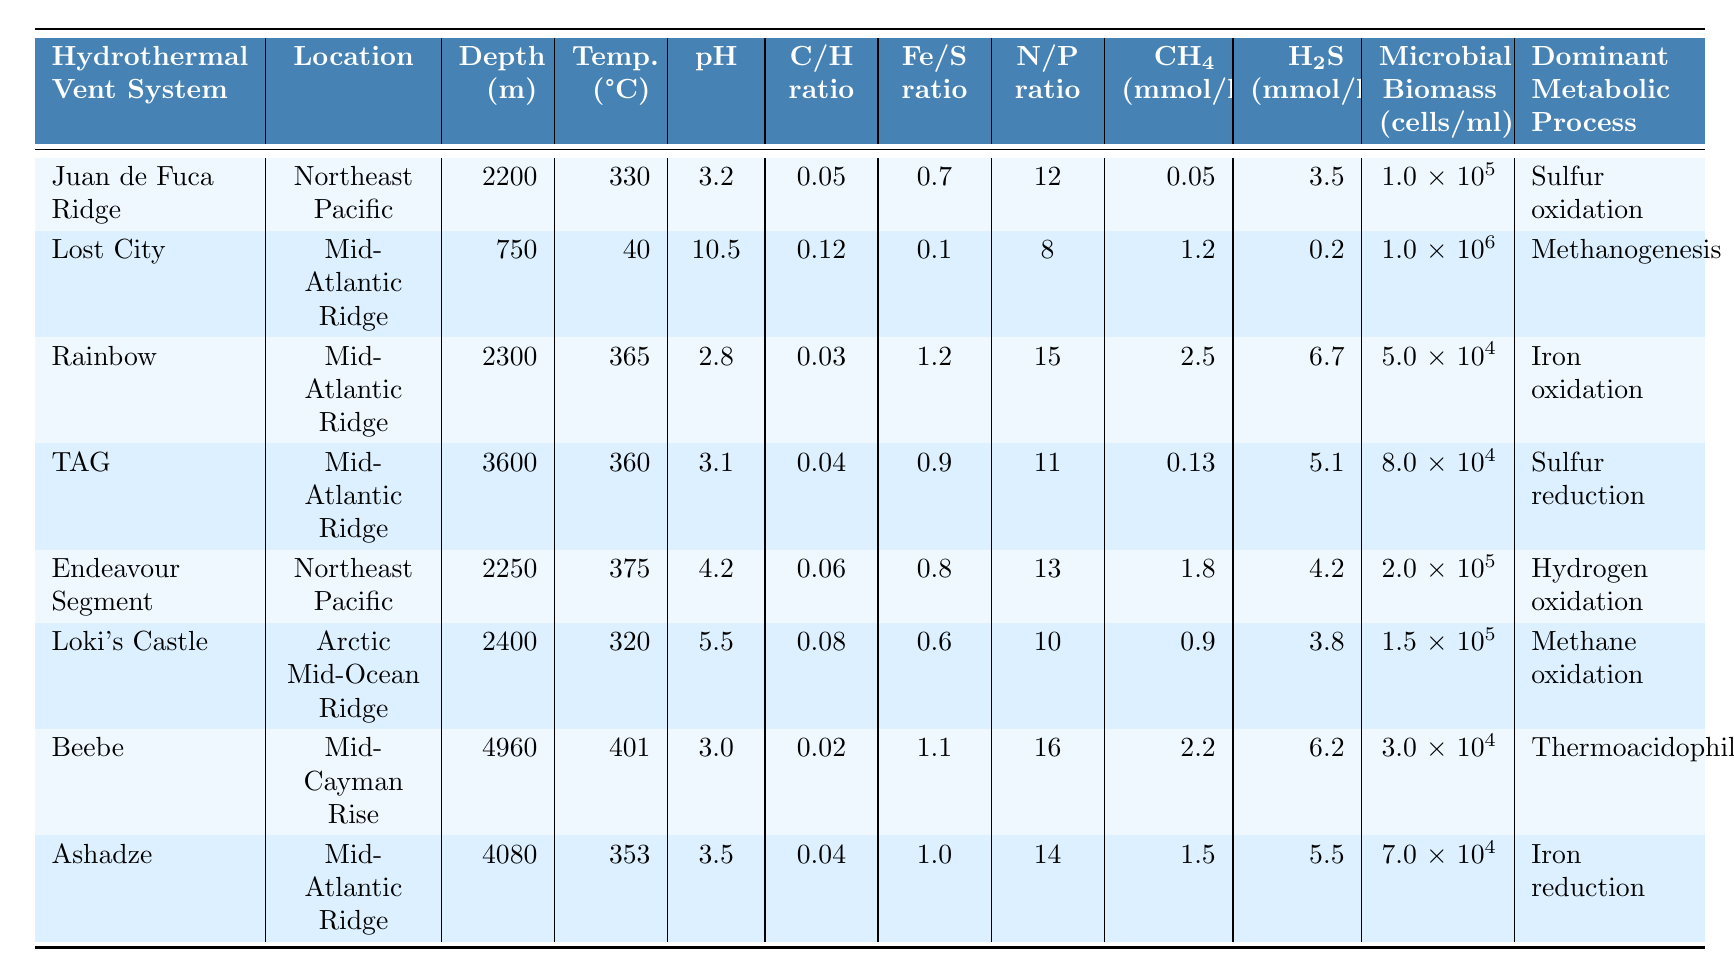What is the highest temperature recorded among the hydrothermal vent systems? Among all the entries in the table, the temperature values are listed as follows: 330, 40, 365, 360, 375, 320, 401, and 353 °C. The highest value is 375 °C from the Endeavour Segment.
Answer: 375 °C Which hydrothermal vent system has the lowest pH value? The pH values listed in the table are: 3.2, 10.5, 2.8, 3.1, 4.2, 5.5, 3.0, and 3.5. The lowest value among these is 2.8, which corresponds to the Rainbow hydrothermal vent system.
Answer: Rainbow What is the C/H ratio for the Lost City hydrothermal vent system? Looking at the table, the C/H ratio for the Lost City is specified to be 0.12.
Answer: 0.12 Calculate the average N/P ratio across all listed hydrothermal vent systems. The N/P ratios provided are 12, 8, 15, 11, 13, 10, 16, and 14. To find the average, we sum these values: 12 + 8 + 15 + 11 + 13 + 10 + 16 + 14 = 99. Then we divide by 8 (the number of systems): 99 / 8 = 12.375.
Answer: 12.375 Which hydrothermal vent system has a higher Methane concentration, Loki's Castle or TAG? From the table, the Methane concentrations are listed as follows: Loki's Castle has 0.9 mmol/kg and TAG has 0.13 mmol/kg. Since 0.9 is greater than 0.13, Loki's Castle has the higher Methane concentration.
Answer: Loki's Castle Is there a hydrothermal vent system with a microbial biomass greater than 1 million cells per milliliter? By reviewing the microbial biomass values: 1e5, 1e6, 5e4, 8e4, 2e5, 1.5e5, 3e4, and 7e4. The value 1e6 is the only one that represents 1 million cells/ml, which is from the Lost City system. Therefore, there is one system with more than 1 million cells.
Answer: Yes What is the difference between the highest and lowest Depth values in meters? The Depth values are listed as: 2200, 750, 2300, 3600, 2250, 2400, 4960, and 4080. The highest value is 4960 m (Beebe) and the lowest is 750 m (Lost City). Finding the difference: 4960 - 750 = 4210 m.
Answer: 4210 m Which hydrothermal vent system shows a dominant metabolic process of Methanogenesis? The table highlights that the Lost City hydrothermal vent system shows Methanogenesis as its dominant metabolic process.
Answer: Lost City Identify the hydrothermal vent system with the highest Fe/S ratio. The Fe/S ratios provided are 0.7, 0.1, 1.2, 0.9, 0.8, 0.6, 1.1, and 1.0. The highest of these is 1.2, which belongs to the Rainbow hydrothermal vent system.
Answer: Rainbow Which two hydrothermal vent systems have a pH greater than 5? The pH values listed are: 3.2, 10.5, 2.8, 3.1, 4.2, 5.5, 3.0, and 3.5. The only systems with a pH greater than 5 are Lost City (10.5) and Loki's Castle (5.5).
Answer: Lost City and Loki's Castle 